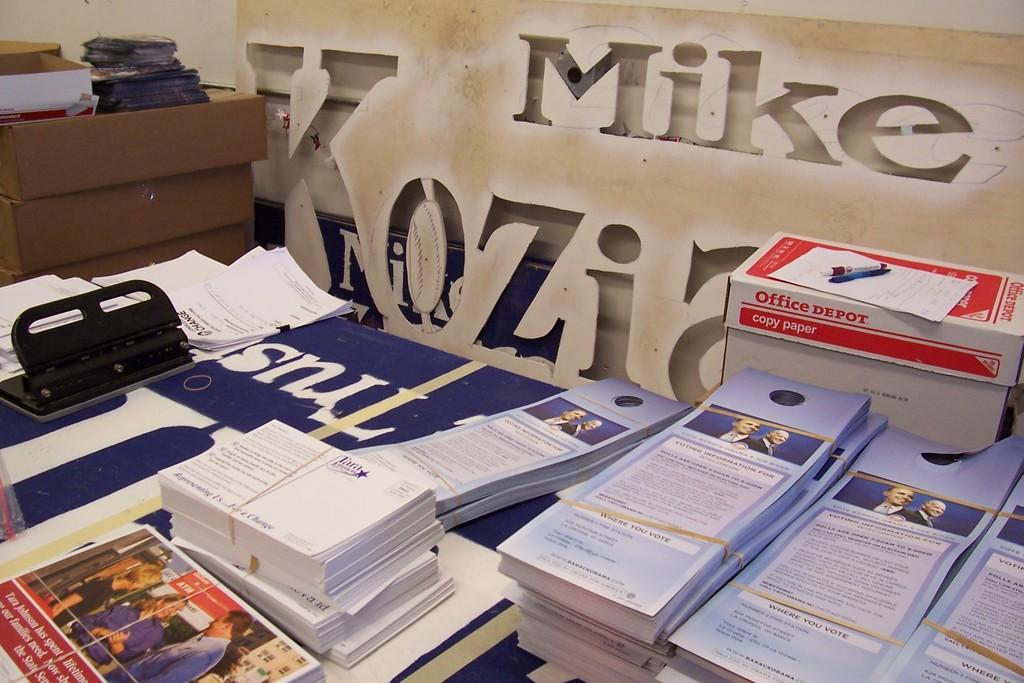<image>
Provide a brief description of the given image. A table is covered with pamphlets with Voting Instructions for Wisconsin and has mailers about Tara Johnson in front of a cutout that says Mike. 